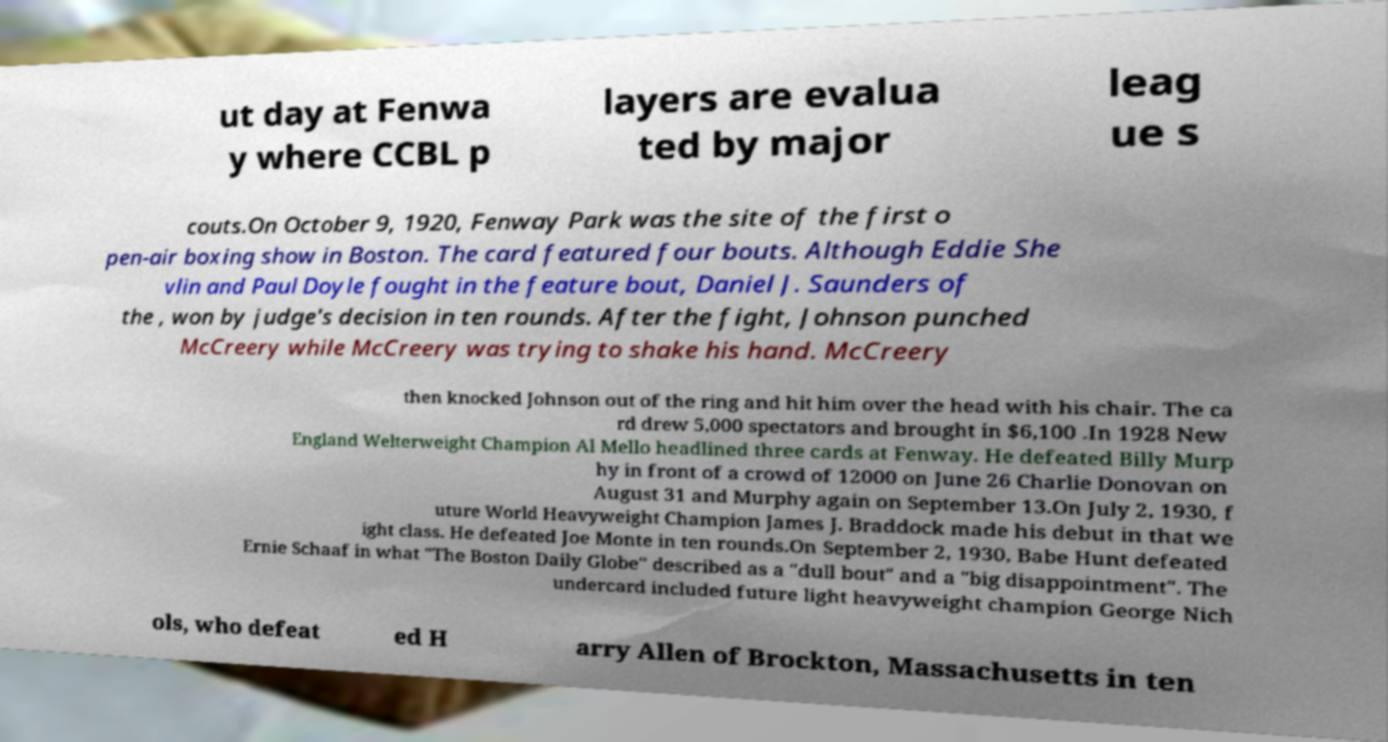Can you read and provide the text displayed in the image?This photo seems to have some interesting text. Can you extract and type it out for me? ut day at Fenwa y where CCBL p layers are evalua ted by major leag ue s couts.On October 9, 1920, Fenway Park was the site of the first o pen-air boxing show in Boston. The card featured four bouts. Although Eddie She vlin and Paul Doyle fought in the feature bout, Daniel J. Saunders of the , won by judge's decision in ten rounds. After the fight, Johnson punched McCreery while McCreery was trying to shake his hand. McCreery then knocked Johnson out of the ring and hit him over the head with his chair. The ca rd drew 5,000 spectators and brought in $6,100 .In 1928 New England Welterweight Champion Al Mello headlined three cards at Fenway. He defeated Billy Murp hy in front of a crowd of 12000 on June 26 Charlie Donovan on August 31 and Murphy again on September 13.On July 2, 1930, f uture World Heavyweight Champion James J. Braddock made his debut in that we ight class. He defeated Joe Monte in ten rounds.On September 2, 1930, Babe Hunt defeated Ernie Schaaf in what "The Boston Daily Globe" described as a "dull bout" and a "big disappointment". The undercard included future light heavyweight champion George Nich ols, who defeat ed H arry Allen of Brockton, Massachusetts in ten 